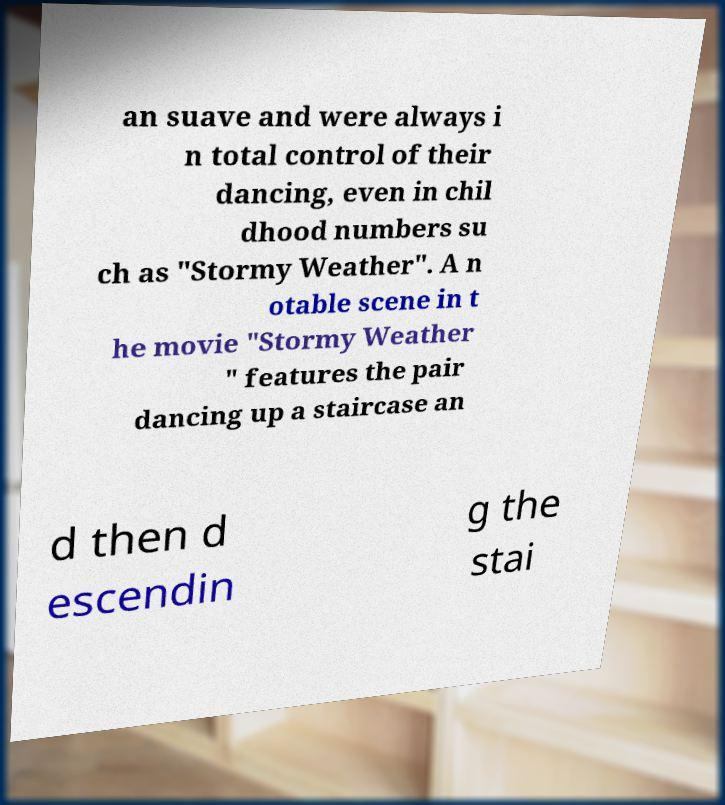Please identify and transcribe the text found in this image. an suave and were always i n total control of their dancing, even in chil dhood numbers su ch as "Stormy Weather". A n otable scene in t he movie "Stormy Weather " features the pair dancing up a staircase an d then d escendin g the stai 